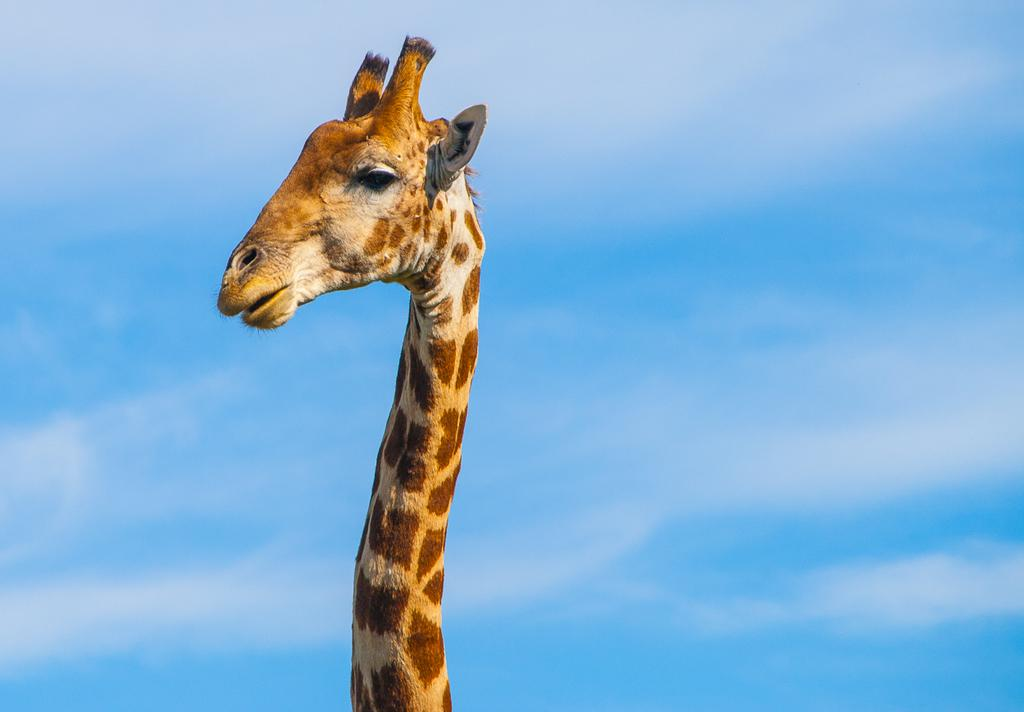What type of animal is in the image? There is a giraffe in the image. What is the condition of the sky in the image? The sky is cloudy in the image. What type of twig can be seen in the giraffe's mouth in the image? There is no twig visible in the giraffe's mouth in the image. What color is the silverware on the table in the image? There is no silverware or table present in the image; it only features a giraffe and a cloudy sky. 